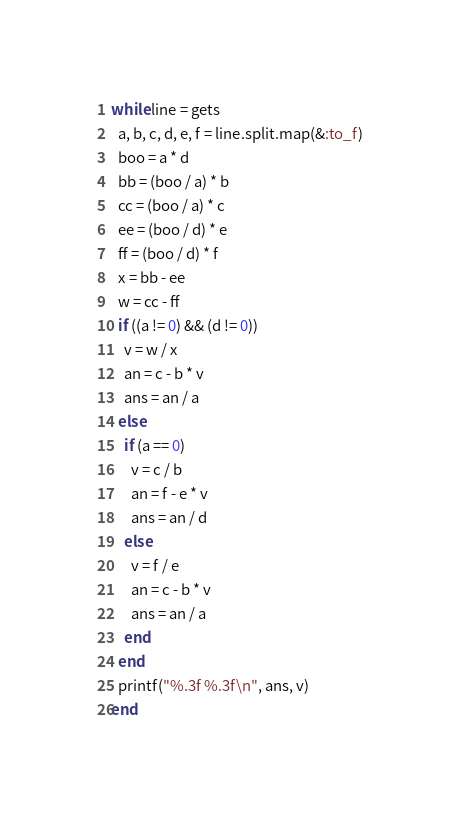Convert code to text. <code><loc_0><loc_0><loc_500><loc_500><_Ruby_>while line = gets
  a, b, c, d, e, f = line.split.map(&:to_f)
  boo = a * d
  bb = (boo / a) * b
  cc = (boo / a) * c
  ee = (boo / d) * e
  ff = (boo / d) * f
  x = bb - ee
  w = cc - ff
  if ((a != 0) && (d != 0))
    v = w / x
    an = c - b * v
    ans = an / a
  else
    if (a == 0)
      v = c / b
      an = f - e * v
      ans = an / d
    else
      v = f / e
      an = c - b * v
      ans = an / a
    end
  end
  printf("%.3f %.3f\n", ans, v)
end</code> 